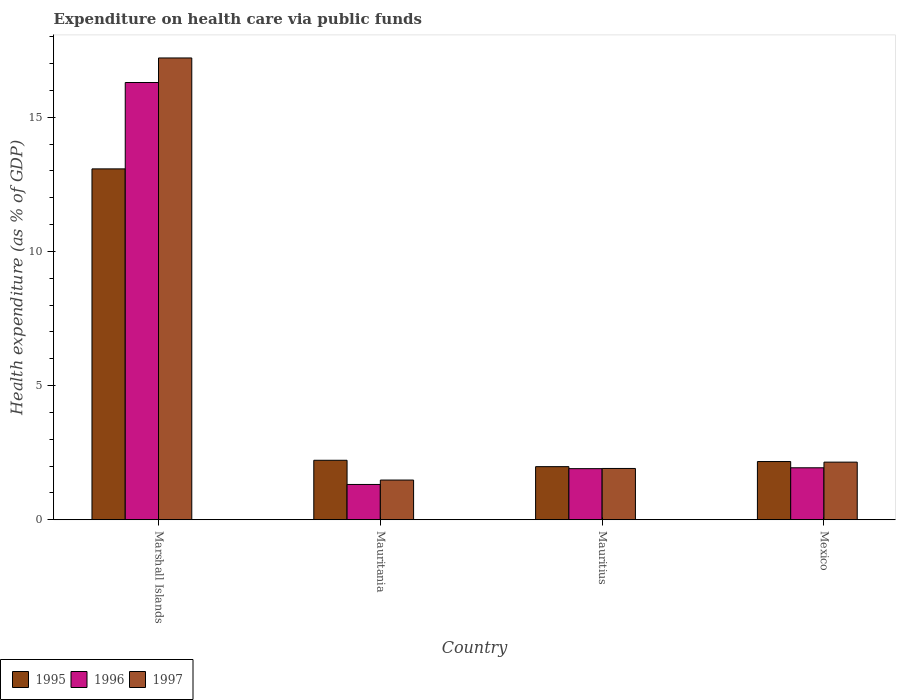How many different coloured bars are there?
Ensure brevity in your answer.  3. Are the number of bars per tick equal to the number of legend labels?
Give a very brief answer. Yes. How many bars are there on the 3rd tick from the left?
Offer a very short reply. 3. How many bars are there on the 4th tick from the right?
Provide a short and direct response. 3. What is the label of the 2nd group of bars from the left?
Give a very brief answer. Mauritania. What is the expenditure made on health care in 1996 in Mexico?
Your answer should be very brief. 1.94. Across all countries, what is the maximum expenditure made on health care in 1997?
Provide a short and direct response. 17.21. Across all countries, what is the minimum expenditure made on health care in 1997?
Offer a very short reply. 1.48. In which country was the expenditure made on health care in 1996 maximum?
Offer a very short reply. Marshall Islands. In which country was the expenditure made on health care in 1995 minimum?
Provide a succinct answer. Mauritius. What is the total expenditure made on health care in 1996 in the graph?
Give a very brief answer. 21.45. What is the difference between the expenditure made on health care in 1995 in Marshall Islands and that in Mexico?
Give a very brief answer. 10.91. What is the difference between the expenditure made on health care in 1995 in Mauritius and the expenditure made on health care in 1996 in Mexico?
Keep it short and to the point. 0.04. What is the average expenditure made on health care in 1996 per country?
Your answer should be very brief. 5.36. What is the difference between the expenditure made on health care of/in 1995 and expenditure made on health care of/in 1996 in Mexico?
Your answer should be compact. 0.23. What is the ratio of the expenditure made on health care in 1996 in Marshall Islands to that in Mauritania?
Offer a terse response. 12.39. What is the difference between the highest and the second highest expenditure made on health care in 1997?
Your response must be concise. 15.06. What is the difference between the highest and the lowest expenditure made on health care in 1997?
Your response must be concise. 15.73. What does the 1st bar from the right in Mauritius represents?
Provide a short and direct response. 1997. Is it the case that in every country, the sum of the expenditure made on health care in 1997 and expenditure made on health care in 1996 is greater than the expenditure made on health care in 1995?
Your response must be concise. Yes. How many countries are there in the graph?
Give a very brief answer. 4. What is the difference between two consecutive major ticks on the Y-axis?
Give a very brief answer. 5. Does the graph contain any zero values?
Provide a succinct answer. No. Where does the legend appear in the graph?
Give a very brief answer. Bottom left. How many legend labels are there?
Your answer should be compact. 3. What is the title of the graph?
Give a very brief answer. Expenditure on health care via public funds. What is the label or title of the Y-axis?
Provide a succinct answer. Health expenditure (as % of GDP). What is the Health expenditure (as % of GDP) of 1995 in Marshall Islands?
Your answer should be compact. 13.08. What is the Health expenditure (as % of GDP) in 1996 in Marshall Islands?
Give a very brief answer. 16.29. What is the Health expenditure (as % of GDP) in 1997 in Marshall Islands?
Keep it short and to the point. 17.21. What is the Health expenditure (as % of GDP) of 1995 in Mauritania?
Offer a terse response. 2.22. What is the Health expenditure (as % of GDP) in 1996 in Mauritania?
Ensure brevity in your answer.  1.32. What is the Health expenditure (as % of GDP) in 1997 in Mauritania?
Offer a terse response. 1.48. What is the Health expenditure (as % of GDP) of 1995 in Mauritius?
Provide a succinct answer. 1.98. What is the Health expenditure (as % of GDP) in 1996 in Mauritius?
Provide a short and direct response. 1.9. What is the Health expenditure (as % of GDP) in 1997 in Mauritius?
Ensure brevity in your answer.  1.91. What is the Health expenditure (as % of GDP) in 1995 in Mexico?
Keep it short and to the point. 2.17. What is the Health expenditure (as % of GDP) of 1996 in Mexico?
Provide a succinct answer. 1.94. What is the Health expenditure (as % of GDP) of 1997 in Mexico?
Give a very brief answer. 2.15. Across all countries, what is the maximum Health expenditure (as % of GDP) in 1995?
Your response must be concise. 13.08. Across all countries, what is the maximum Health expenditure (as % of GDP) of 1996?
Offer a terse response. 16.29. Across all countries, what is the maximum Health expenditure (as % of GDP) in 1997?
Offer a terse response. 17.21. Across all countries, what is the minimum Health expenditure (as % of GDP) in 1995?
Provide a succinct answer. 1.98. Across all countries, what is the minimum Health expenditure (as % of GDP) of 1996?
Keep it short and to the point. 1.32. Across all countries, what is the minimum Health expenditure (as % of GDP) in 1997?
Ensure brevity in your answer.  1.48. What is the total Health expenditure (as % of GDP) of 1995 in the graph?
Offer a very short reply. 19.44. What is the total Health expenditure (as % of GDP) of 1996 in the graph?
Offer a terse response. 21.45. What is the total Health expenditure (as % of GDP) of 1997 in the graph?
Provide a short and direct response. 22.75. What is the difference between the Health expenditure (as % of GDP) of 1995 in Marshall Islands and that in Mauritania?
Your response must be concise. 10.86. What is the difference between the Health expenditure (as % of GDP) of 1996 in Marshall Islands and that in Mauritania?
Provide a succinct answer. 14.98. What is the difference between the Health expenditure (as % of GDP) of 1997 in Marshall Islands and that in Mauritania?
Offer a very short reply. 15.73. What is the difference between the Health expenditure (as % of GDP) of 1995 in Marshall Islands and that in Mauritius?
Keep it short and to the point. 11.1. What is the difference between the Health expenditure (as % of GDP) of 1996 in Marshall Islands and that in Mauritius?
Provide a short and direct response. 14.39. What is the difference between the Health expenditure (as % of GDP) of 1997 in Marshall Islands and that in Mauritius?
Keep it short and to the point. 15.3. What is the difference between the Health expenditure (as % of GDP) in 1995 in Marshall Islands and that in Mexico?
Keep it short and to the point. 10.91. What is the difference between the Health expenditure (as % of GDP) in 1996 in Marshall Islands and that in Mexico?
Your response must be concise. 14.36. What is the difference between the Health expenditure (as % of GDP) of 1997 in Marshall Islands and that in Mexico?
Give a very brief answer. 15.06. What is the difference between the Health expenditure (as % of GDP) of 1995 in Mauritania and that in Mauritius?
Offer a very short reply. 0.24. What is the difference between the Health expenditure (as % of GDP) of 1996 in Mauritania and that in Mauritius?
Your answer should be compact. -0.59. What is the difference between the Health expenditure (as % of GDP) of 1997 in Mauritania and that in Mauritius?
Offer a very short reply. -0.43. What is the difference between the Health expenditure (as % of GDP) of 1995 in Mauritania and that in Mexico?
Offer a terse response. 0.05. What is the difference between the Health expenditure (as % of GDP) in 1996 in Mauritania and that in Mexico?
Your response must be concise. -0.62. What is the difference between the Health expenditure (as % of GDP) in 1997 in Mauritania and that in Mexico?
Provide a short and direct response. -0.67. What is the difference between the Health expenditure (as % of GDP) in 1995 in Mauritius and that in Mexico?
Your answer should be very brief. -0.19. What is the difference between the Health expenditure (as % of GDP) in 1996 in Mauritius and that in Mexico?
Provide a succinct answer. -0.03. What is the difference between the Health expenditure (as % of GDP) in 1997 in Mauritius and that in Mexico?
Give a very brief answer. -0.24. What is the difference between the Health expenditure (as % of GDP) of 1995 in Marshall Islands and the Health expenditure (as % of GDP) of 1996 in Mauritania?
Your answer should be very brief. 11.76. What is the difference between the Health expenditure (as % of GDP) of 1995 in Marshall Islands and the Health expenditure (as % of GDP) of 1997 in Mauritania?
Your answer should be very brief. 11.6. What is the difference between the Health expenditure (as % of GDP) in 1996 in Marshall Islands and the Health expenditure (as % of GDP) in 1997 in Mauritania?
Provide a succinct answer. 14.81. What is the difference between the Health expenditure (as % of GDP) in 1995 in Marshall Islands and the Health expenditure (as % of GDP) in 1996 in Mauritius?
Give a very brief answer. 11.17. What is the difference between the Health expenditure (as % of GDP) of 1995 in Marshall Islands and the Health expenditure (as % of GDP) of 1997 in Mauritius?
Your response must be concise. 11.16. What is the difference between the Health expenditure (as % of GDP) in 1996 in Marshall Islands and the Health expenditure (as % of GDP) in 1997 in Mauritius?
Give a very brief answer. 14.38. What is the difference between the Health expenditure (as % of GDP) in 1995 in Marshall Islands and the Health expenditure (as % of GDP) in 1996 in Mexico?
Give a very brief answer. 11.14. What is the difference between the Health expenditure (as % of GDP) of 1995 in Marshall Islands and the Health expenditure (as % of GDP) of 1997 in Mexico?
Offer a terse response. 10.93. What is the difference between the Health expenditure (as % of GDP) of 1996 in Marshall Islands and the Health expenditure (as % of GDP) of 1997 in Mexico?
Your answer should be very brief. 14.15. What is the difference between the Health expenditure (as % of GDP) in 1995 in Mauritania and the Health expenditure (as % of GDP) in 1996 in Mauritius?
Your answer should be compact. 0.31. What is the difference between the Health expenditure (as % of GDP) in 1995 in Mauritania and the Health expenditure (as % of GDP) in 1997 in Mauritius?
Make the answer very short. 0.31. What is the difference between the Health expenditure (as % of GDP) of 1996 in Mauritania and the Health expenditure (as % of GDP) of 1997 in Mauritius?
Your response must be concise. -0.6. What is the difference between the Health expenditure (as % of GDP) of 1995 in Mauritania and the Health expenditure (as % of GDP) of 1996 in Mexico?
Give a very brief answer. 0.28. What is the difference between the Health expenditure (as % of GDP) in 1995 in Mauritania and the Health expenditure (as % of GDP) in 1997 in Mexico?
Keep it short and to the point. 0.07. What is the difference between the Health expenditure (as % of GDP) in 1996 in Mauritania and the Health expenditure (as % of GDP) in 1997 in Mexico?
Ensure brevity in your answer.  -0.83. What is the difference between the Health expenditure (as % of GDP) in 1995 in Mauritius and the Health expenditure (as % of GDP) in 1996 in Mexico?
Offer a terse response. 0.04. What is the difference between the Health expenditure (as % of GDP) in 1995 in Mauritius and the Health expenditure (as % of GDP) in 1997 in Mexico?
Keep it short and to the point. -0.17. What is the difference between the Health expenditure (as % of GDP) of 1996 in Mauritius and the Health expenditure (as % of GDP) of 1997 in Mexico?
Make the answer very short. -0.24. What is the average Health expenditure (as % of GDP) of 1995 per country?
Your answer should be very brief. 4.86. What is the average Health expenditure (as % of GDP) in 1996 per country?
Your answer should be very brief. 5.36. What is the average Health expenditure (as % of GDP) of 1997 per country?
Offer a very short reply. 5.69. What is the difference between the Health expenditure (as % of GDP) of 1995 and Health expenditure (as % of GDP) of 1996 in Marshall Islands?
Make the answer very short. -3.22. What is the difference between the Health expenditure (as % of GDP) in 1995 and Health expenditure (as % of GDP) in 1997 in Marshall Islands?
Your response must be concise. -4.13. What is the difference between the Health expenditure (as % of GDP) of 1996 and Health expenditure (as % of GDP) of 1997 in Marshall Islands?
Keep it short and to the point. -0.91. What is the difference between the Health expenditure (as % of GDP) in 1995 and Health expenditure (as % of GDP) in 1996 in Mauritania?
Ensure brevity in your answer.  0.9. What is the difference between the Health expenditure (as % of GDP) of 1995 and Health expenditure (as % of GDP) of 1997 in Mauritania?
Provide a succinct answer. 0.74. What is the difference between the Health expenditure (as % of GDP) of 1996 and Health expenditure (as % of GDP) of 1997 in Mauritania?
Make the answer very short. -0.16. What is the difference between the Health expenditure (as % of GDP) of 1995 and Health expenditure (as % of GDP) of 1996 in Mauritius?
Keep it short and to the point. 0.07. What is the difference between the Health expenditure (as % of GDP) of 1995 and Health expenditure (as % of GDP) of 1997 in Mauritius?
Provide a succinct answer. 0.07. What is the difference between the Health expenditure (as % of GDP) in 1996 and Health expenditure (as % of GDP) in 1997 in Mauritius?
Your response must be concise. -0.01. What is the difference between the Health expenditure (as % of GDP) in 1995 and Health expenditure (as % of GDP) in 1996 in Mexico?
Keep it short and to the point. 0.23. What is the difference between the Health expenditure (as % of GDP) in 1995 and Health expenditure (as % of GDP) in 1997 in Mexico?
Offer a terse response. 0.02. What is the difference between the Health expenditure (as % of GDP) of 1996 and Health expenditure (as % of GDP) of 1997 in Mexico?
Ensure brevity in your answer.  -0.21. What is the ratio of the Health expenditure (as % of GDP) in 1995 in Marshall Islands to that in Mauritania?
Offer a very short reply. 5.9. What is the ratio of the Health expenditure (as % of GDP) of 1996 in Marshall Islands to that in Mauritania?
Make the answer very short. 12.39. What is the ratio of the Health expenditure (as % of GDP) of 1997 in Marshall Islands to that in Mauritania?
Ensure brevity in your answer.  11.63. What is the ratio of the Health expenditure (as % of GDP) of 1995 in Marshall Islands to that in Mauritius?
Make the answer very short. 6.61. What is the ratio of the Health expenditure (as % of GDP) of 1996 in Marshall Islands to that in Mauritius?
Offer a very short reply. 8.55. What is the ratio of the Health expenditure (as % of GDP) in 1997 in Marshall Islands to that in Mauritius?
Ensure brevity in your answer.  9. What is the ratio of the Health expenditure (as % of GDP) of 1995 in Marshall Islands to that in Mexico?
Your response must be concise. 6.03. What is the ratio of the Health expenditure (as % of GDP) of 1996 in Marshall Islands to that in Mexico?
Your answer should be compact. 8.41. What is the ratio of the Health expenditure (as % of GDP) in 1997 in Marshall Islands to that in Mexico?
Keep it short and to the point. 8.01. What is the ratio of the Health expenditure (as % of GDP) in 1995 in Mauritania to that in Mauritius?
Give a very brief answer. 1.12. What is the ratio of the Health expenditure (as % of GDP) of 1996 in Mauritania to that in Mauritius?
Your answer should be very brief. 0.69. What is the ratio of the Health expenditure (as % of GDP) in 1997 in Mauritania to that in Mauritius?
Ensure brevity in your answer.  0.77. What is the ratio of the Health expenditure (as % of GDP) of 1995 in Mauritania to that in Mexico?
Provide a short and direct response. 1.02. What is the ratio of the Health expenditure (as % of GDP) in 1996 in Mauritania to that in Mexico?
Offer a terse response. 0.68. What is the ratio of the Health expenditure (as % of GDP) in 1997 in Mauritania to that in Mexico?
Your answer should be compact. 0.69. What is the ratio of the Health expenditure (as % of GDP) of 1995 in Mauritius to that in Mexico?
Provide a succinct answer. 0.91. What is the ratio of the Health expenditure (as % of GDP) of 1996 in Mauritius to that in Mexico?
Offer a terse response. 0.98. What is the ratio of the Health expenditure (as % of GDP) of 1997 in Mauritius to that in Mexico?
Keep it short and to the point. 0.89. What is the difference between the highest and the second highest Health expenditure (as % of GDP) of 1995?
Offer a very short reply. 10.86. What is the difference between the highest and the second highest Health expenditure (as % of GDP) of 1996?
Give a very brief answer. 14.36. What is the difference between the highest and the second highest Health expenditure (as % of GDP) in 1997?
Offer a very short reply. 15.06. What is the difference between the highest and the lowest Health expenditure (as % of GDP) of 1995?
Your answer should be compact. 11.1. What is the difference between the highest and the lowest Health expenditure (as % of GDP) in 1996?
Your response must be concise. 14.98. What is the difference between the highest and the lowest Health expenditure (as % of GDP) of 1997?
Offer a terse response. 15.73. 